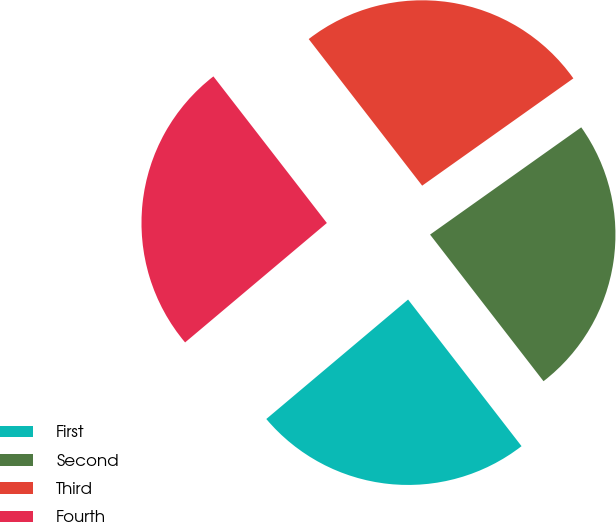<chart> <loc_0><loc_0><loc_500><loc_500><pie_chart><fcel>First<fcel>Second<fcel>Third<fcel>Fourth<nl><fcel>24.34%<fcel>24.34%<fcel>25.66%<fcel>25.66%<nl></chart> 